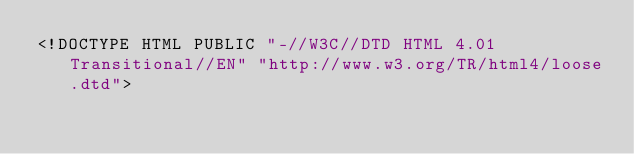<code> <loc_0><loc_0><loc_500><loc_500><_HTML_><!DOCTYPE HTML PUBLIC "-//W3C//DTD HTML 4.01 Transitional//EN" "http://www.w3.org/TR/html4/loose.dtd"></code> 